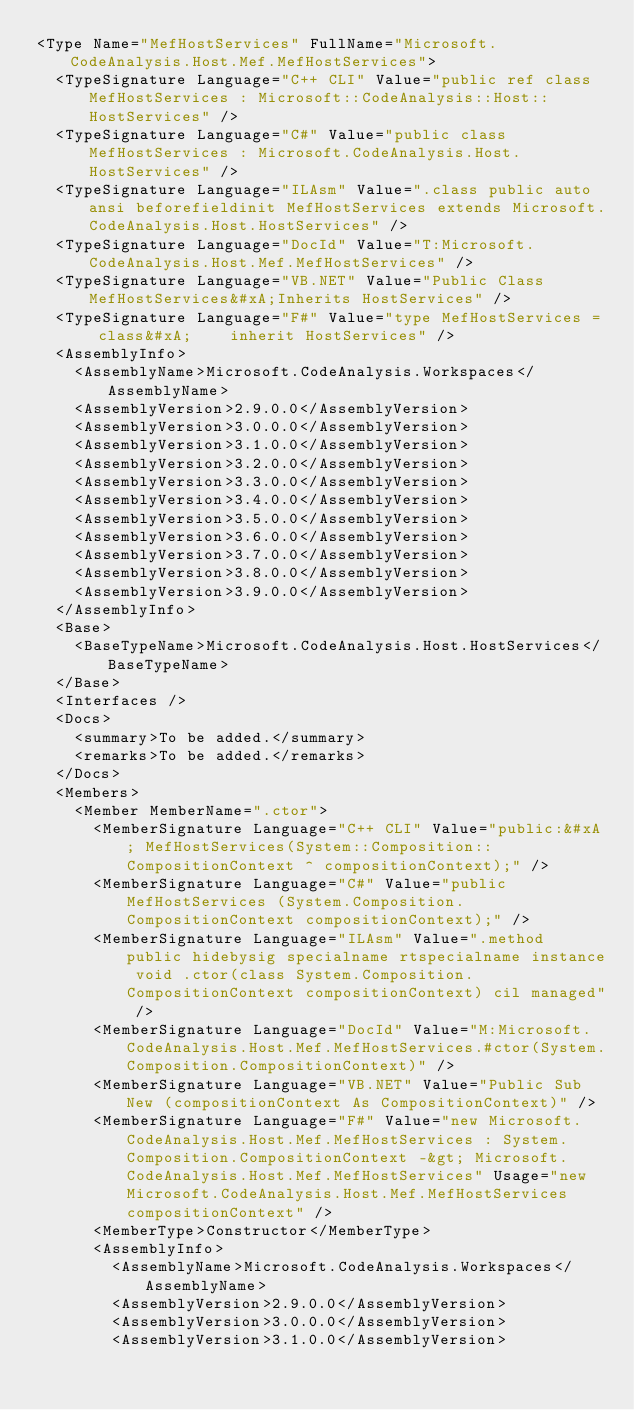<code> <loc_0><loc_0><loc_500><loc_500><_XML_><Type Name="MefHostServices" FullName="Microsoft.CodeAnalysis.Host.Mef.MefHostServices">
  <TypeSignature Language="C++ CLI" Value="public ref class MefHostServices : Microsoft::CodeAnalysis::Host::HostServices" />
  <TypeSignature Language="C#" Value="public class MefHostServices : Microsoft.CodeAnalysis.Host.HostServices" />
  <TypeSignature Language="ILAsm" Value=".class public auto ansi beforefieldinit MefHostServices extends Microsoft.CodeAnalysis.Host.HostServices" />
  <TypeSignature Language="DocId" Value="T:Microsoft.CodeAnalysis.Host.Mef.MefHostServices" />
  <TypeSignature Language="VB.NET" Value="Public Class MefHostServices&#xA;Inherits HostServices" />
  <TypeSignature Language="F#" Value="type MefHostServices = class&#xA;    inherit HostServices" />
  <AssemblyInfo>
    <AssemblyName>Microsoft.CodeAnalysis.Workspaces</AssemblyName>
    <AssemblyVersion>2.9.0.0</AssemblyVersion>
    <AssemblyVersion>3.0.0.0</AssemblyVersion>
    <AssemblyVersion>3.1.0.0</AssemblyVersion>
    <AssemblyVersion>3.2.0.0</AssemblyVersion>
    <AssemblyVersion>3.3.0.0</AssemblyVersion>
    <AssemblyVersion>3.4.0.0</AssemblyVersion>
    <AssemblyVersion>3.5.0.0</AssemblyVersion>
    <AssemblyVersion>3.6.0.0</AssemblyVersion>
    <AssemblyVersion>3.7.0.0</AssemblyVersion>
    <AssemblyVersion>3.8.0.0</AssemblyVersion>
    <AssemblyVersion>3.9.0.0</AssemblyVersion>
  </AssemblyInfo>
  <Base>
    <BaseTypeName>Microsoft.CodeAnalysis.Host.HostServices</BaseTypeName>
  </Base>
  <Interfaces />
  <Docs>
    <summary>To be added.</summary>
    <remarks>To be added.</remarks>
  </Docs>
  <Members>
    <Member MemberName=".ctor">
      <MemberSignature Language="C++ CLI" Value="public:&#xA; MefHostServices(System::Composition::CompositionContext ^ compositionContext);" />
      <MemberSignature Language="C#" Value="public MefHostServices (System.Composition.CompositionContext compositionContext);" />
      <MemberSignature Language="ILAsm" Value=".method public hidebysig specialname rtspecialname instance void .ctor(class System.Composition.CompositionContext compositionContext) cil managed" />
      <MemberSignature Language="DocId" Value="M:Microsoft.CodeAnalysis.Host.Mef.MefHostServices.#ctor(System.Composition.CompositionContext)" />
      <MemberSignature Language="VB.NET" Value="Public Sub New (compositionContext As CompositionContext)" />
      <MemberSignature Language="F#" Value="new Microsoft.CodeAnalysis.Host.Mef.MefHostServices : System.Composition.CompositionContext -&gt; Microsoft.CodeAnalysis.Host.Mef.MefHostServices" Usage="new Microsoft.CodeAnalysis.Host.Mef.MefHostServices compositionContext" />
      <MemberType>Constructor</MemberType>
      <AssemblyInfo>
        <AssemblyName>Microsoft.CodeAnalysis.Workspaces</AssemblyName>
        <AssemblyVersion>2.9.0.0</AssemblyVersion>
        <AssemblyVersion>3.0.0.0</AssemblyVersion>
        <AssemblyVersion>3.1.0.0</AssemblyVersion></code> 